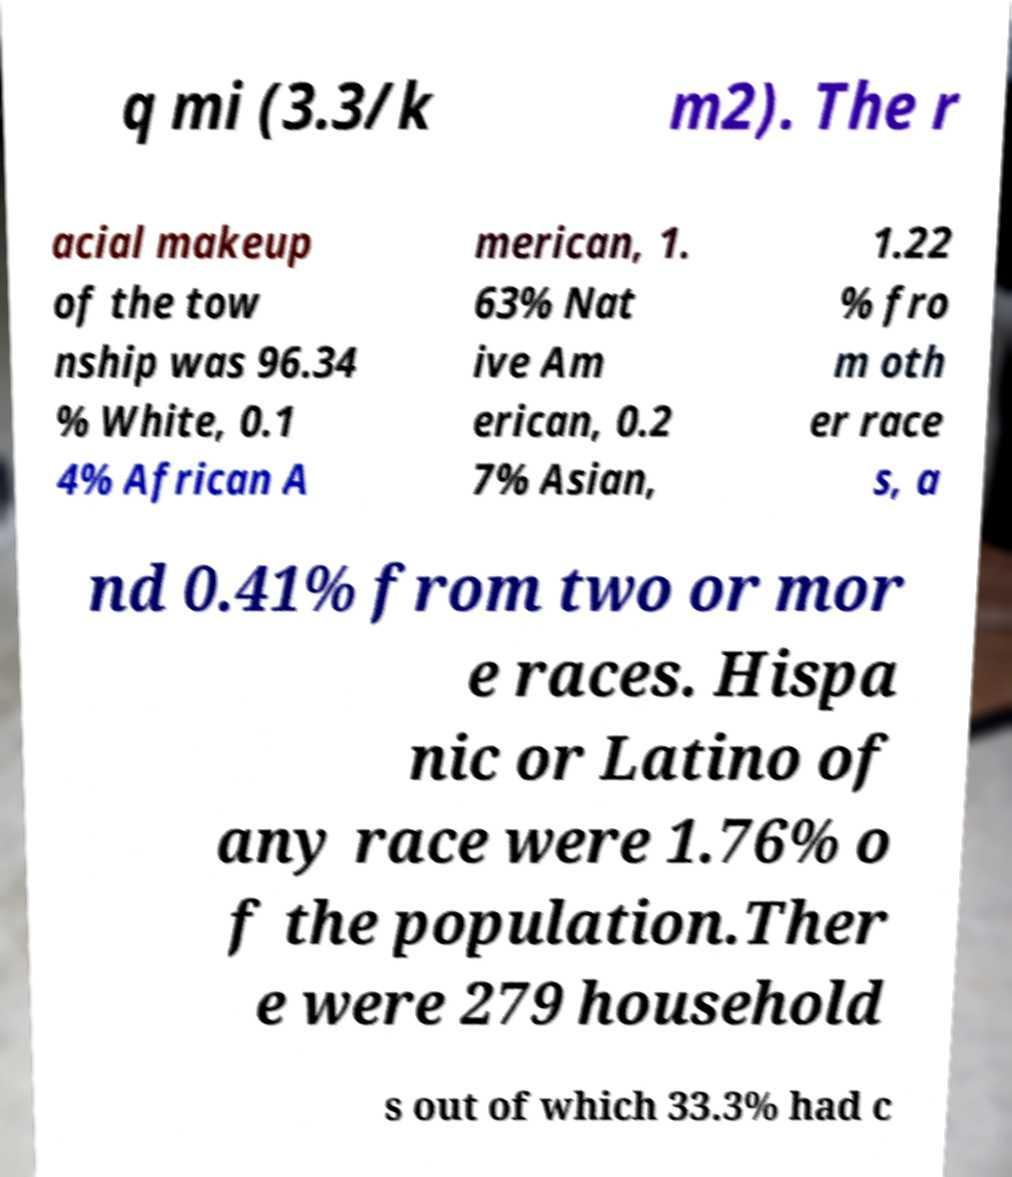I need the written content from this picture converted into text. Can you do that? q mi (3.3/k m2). The r acial makeup of the tow nship was 96.34 % White, 0.1 4% African A merican, 1. 63% Nat ive Am erican, 0.2 7% Asian, 1.22 % fro m oth er race s, a nd 0.41% from two or mor e races. Hispa nic or Latino of any race were 1.76% o f the population.Ther e were 279 household s out of which 33.3% had c 